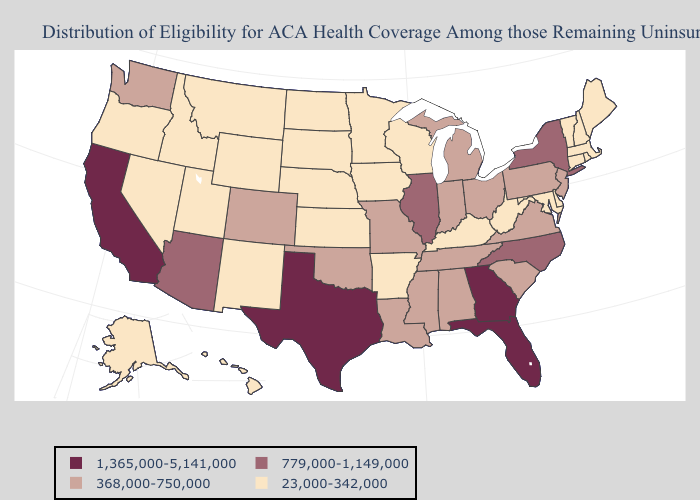Does the map have missing data?
Quick response, please. No. Name the states that have a value in the range 368,000-750,000?
Give a very brief answer. Alabama, Colorado, Indiana, Louisiana, Michigan, Mississippi, Missouri, New Jersey, Ohio, Oklahoma, Pennsylvania, South Carolina, Tennessee, Virginia, Washington. What is the highest value in the South ?
Short answer required. 1,365,000-5,141,000. Name the states that have a value in the range 1,365,000-5,141,000?
Be succinct. California, Florida, Georgia, Texas. Name the states that have a value in the range 368,000-750,000?
Concise answer only. Alabama, Colorado, Indiana, Louisiana, Michigan, Mississippi, Missouri, New Jersey, Ohio, Oklahoma, Pennsylvania, South Carolina, Tennessee, Virginia, Washington. Name the states that have a value in the range 368,000-750,000?
Keep it brief. Alabama, Colorado, Indiana, Louisiana, Michigan, Mississippi, Missouri, New Jersey, Ohio, Oklahoma, Pennsylvania, South Carolina, Tennessee, Virginia, Washington. Does New Jersey have a higher value than North Dakota?
Write a very short answer. Yes. Name the states that have a value in the range 23,000-342,000?
Concise answer only. Alaska, Arkansas, Connecticut, Delaware, Hawaii, Idaho, Iowa, Kansas, Kentucky, Maine, Maryland, Massachusetts, Minnesota, Montana, Nebraska, Nevada, New Hampshire, New Mexico, North Dakota, Oregon, Rhode Island, South Dakota, Utah, Vermont, West Virginia, Wisconsin, Wyoming. Name the states that have a value in the range 23,000-342,000?
Keep it brief. Alaska, Arkansas, Connecticut, Delaware, Hawaii, Idaho, Iowa, Kansas, Kentucky, Maine, Maryland, Massachusetts, Minnesota, Montana, Nebraska, Nevada, New Hampshire, New Mexico, North Dakota, Oregon, Rhode Island, South Dakota, Utah, Vermont, West Virginia, Wisconsin, Wyoming. How many symbols are there in the legend?
Give a very brief answer. 4. What is the highest value in the USA?
Quick response, please. 1,365,000-5,141,000. Among the states that border Michigan , does Indiana have the highest value?
Answer briefly. Yes. Does Arizona have a higher value than California?
Answer briefly. No. Does Oklahoma have the highest value in the South?
Keep it brief. No. Name the states that have a value in the range 23,000-342,000?
Write a very short answer. Alaska, Arkansas, Connecticut, Delaware, Hawaii, Idaho, Iowa, Kansas, Kentucky, Maine, Maryland, Massachusetts, Minnesota, Montana, Nebraska, Nevada, New Hampshire, New Mexico, North Dakota, Oregon, Rhode Island, South Dakota, Utah, Vermont, West Virginia, Wisconsin, Wyoming. 